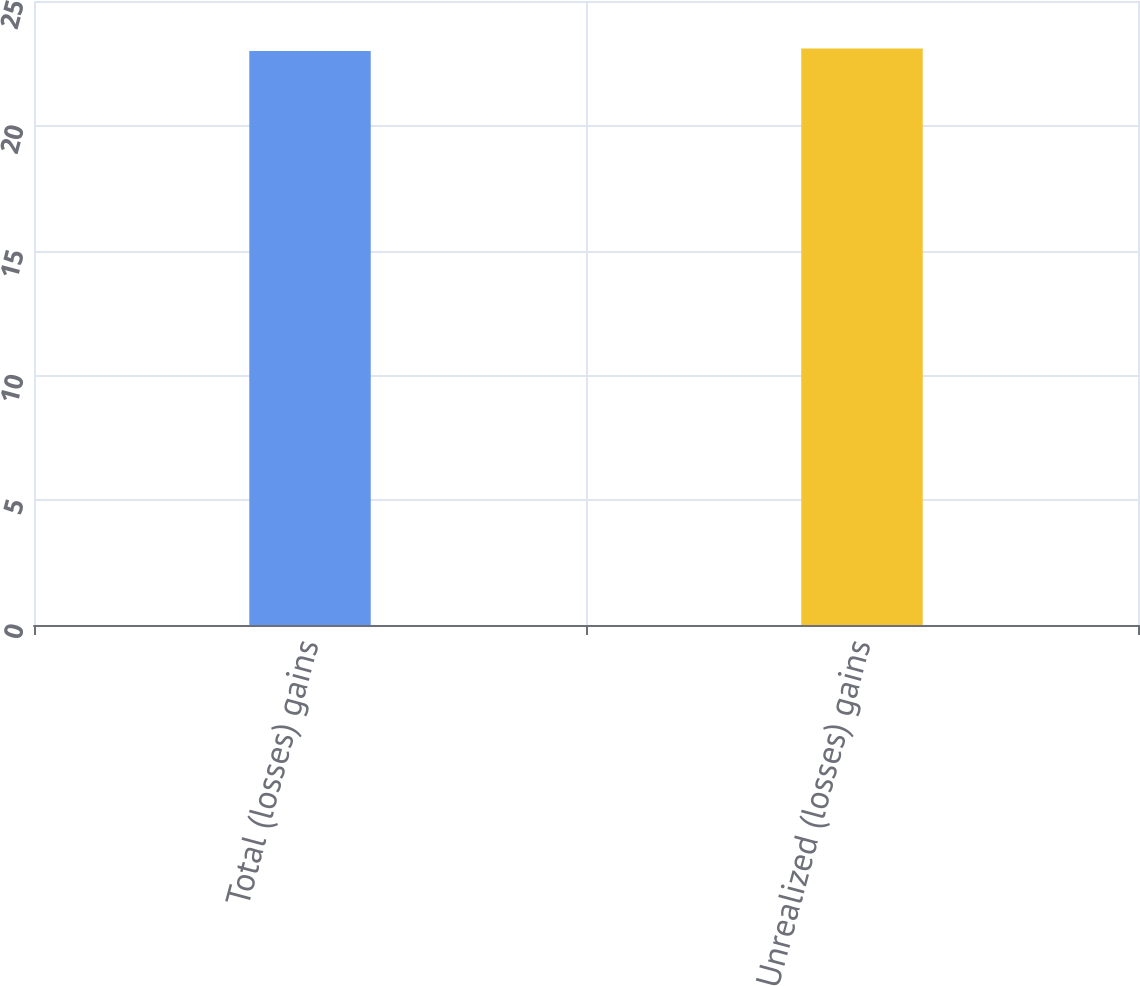Convert chart. <chart><loc_0><loc_0><loc_500><loc_500><bar_chart><fcel>Total (losses) gains<fcel>Unrealized (losses) gains<nl><fcel>23<fcel>23.1<nl></chart> 